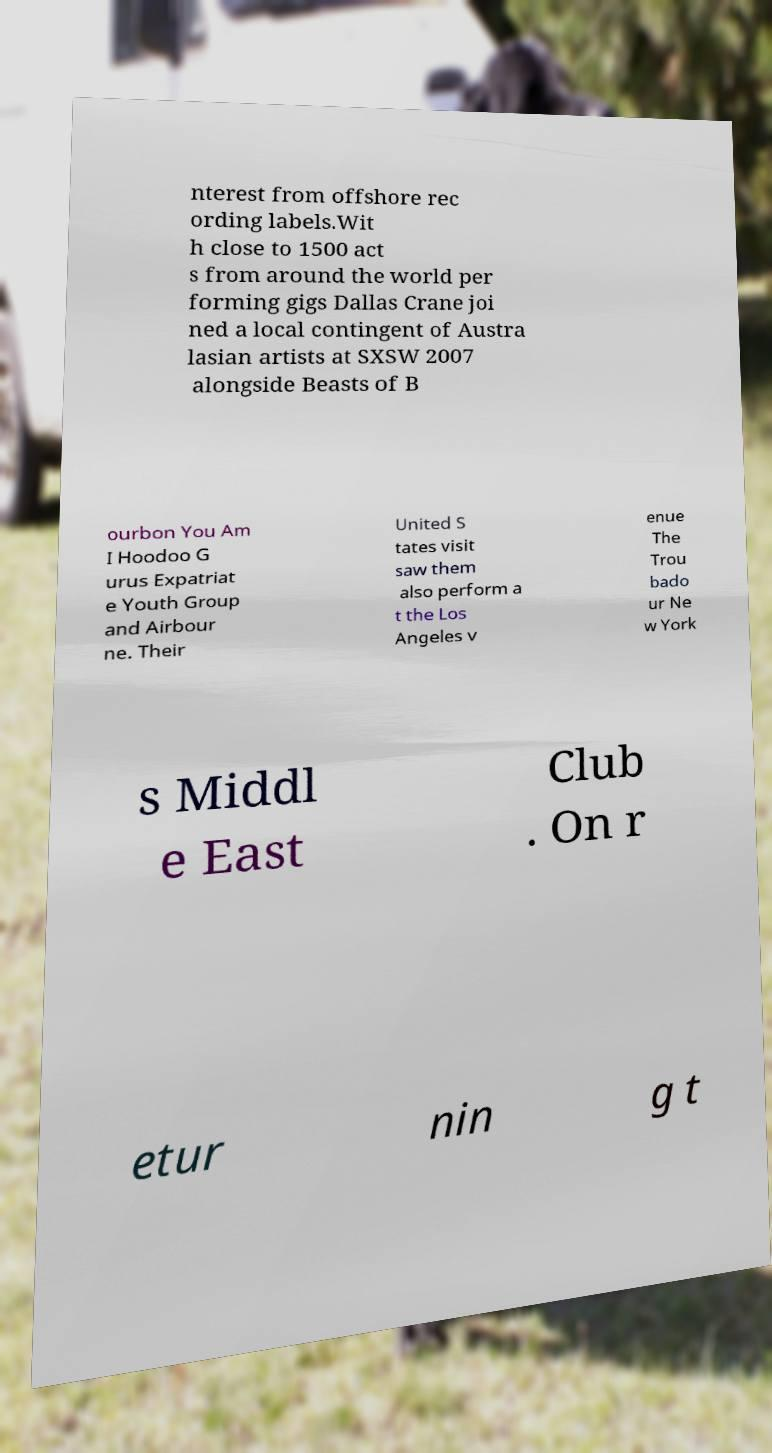Please read and relay the text visible in this image. What does it say? nterest from offshore rec ording labels.Wit h close to 1500 act s from around the world per forming gigs Dallas Crane joi ned a local contingent of Austra lasian artists at SXSW 2007 alongside Beasts of B ourbon You Am I Hoodoo G urus Expatriat e Youth Group and Airbour ne. Their United S tates visit saw them also perform a t the Los Angeles v enue The Trou bado ur Ne w York s Middl e East Club . On r etur nin g t 